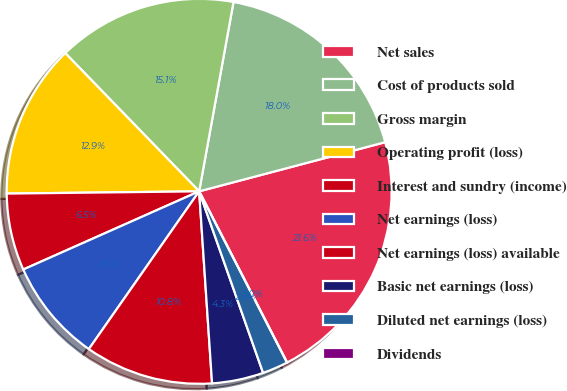Convert chart. <chart><loc_0><loc_0><loc_500><loc_500><pie_chart><fcel>Net sales<fcel>Cost of products sold<fcel>Gross margin<fcel>Operating profit (loss)<fcel>Interest and sundry (income)<fcel>Net earnings (loss)<fcel>Net earnings (loss) available<fcel>Basic net earnings (loss)<fcel>Diluted net earnings (loss)<fcel>Dividends<nl><fcel>21.56%<fcel>18.03%<fcel>15.1%<fcel>12.94%<fcel>6.47%<fcel>8.63%<fcel>10.78%<fcel>4.32%<fcel>2.16%<fcel>0.0%<nl></chart> 